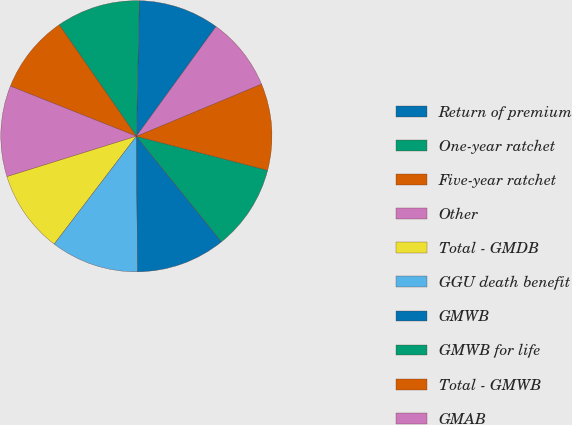<chart> <loc_0><loc_0><loc_500><loc_500><pie_chart><fcel>Return of premium<fcel>One-year ratchet<fcel>Five-year ratchet<fcel>Other<fcel>Total - GMDB<fcel>GGU death benefit<fcel>GMWB<fcel>GMWB for life<fcel>Total - GMWB<fcel>GMAB<nl><fcel>9.65%<fcel>9.99%<fcel>9.33%<fcel>10.84%<fcel>9.82%<fcel>10.5%<fcel>10.67%<fcel>10.16%<fcel>10.33%<fcel>8.71%<nl></chart> 